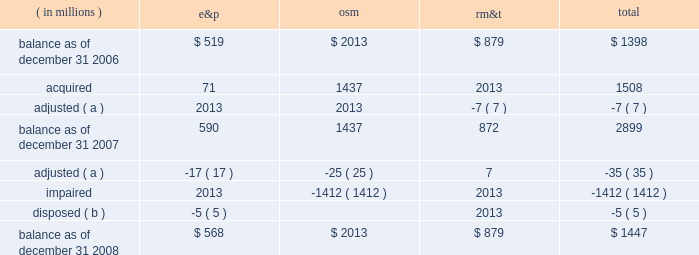Marathon oil corporation notes to consolidated financial statements the changes in the carrying amount of goodwill for the years ended december 31 , 2007 , and 2008 , were as follows : ( in millions ) e&p osm rm&t total .
( a ) adjustments related to prior period income tax and royalty adjustments .
( b ) goodwill was allocated to the norwegian outside-operated properties sold in 2008 .
17 .
Fair value measurements as defined in sfas no .
157 , fair value is the price that would be received to sell an asset or paid to transfer a liability in an orderly transaction between market participants at the measurement date .
Sfas no .
157 describes three approaches to measuring the fair value of assets and liabilities : the market approach , the income approach and the cost approach , each of which includes multiple valuation techniques .
The market approach uses prices and other relevant information generated by market transactions involving identical or comparable assets or liabilities .
The income approach uses valuation techniques to measure fair value by converting future amounts , such as cash flows or earnings , into a single present value amount using current market expectations about those future amounts .
The cost approach is based on the amount that would currently be required to replace the service capacity of an asset .
This is often referred to as current replacement cost .
The cost approach assumes that the fair value would not exceed what it would cost a market participant to acquire or construct a substitute asset of comparable utility , adjusted for obsolescence .
Sfas no .
157 does not prescribe which valuation technique should be used when measuring fair value and does not prioritize among the techniques .
Sfas no .
157 establishes a fair value hierarchy that prioritizes the inputs used in applying the various valuation techniques .
Inputs broadly refer to the assumptions that market participants use to make pricing decisions , including assumptions about risk .
Level 1 inputs are given the highest priority in the fair value hierarchy while level 3 inputs are given the lowest priority .
The three levels of the fair value hierarchy are as follows .
2022 level 1 2013 observable inputs that reflect unadjusted quoted prices for identical assets or liabilities in active markets as of the reporting date .
Active markets are those in which transactions for the asset or liability occur in sufficient frequency and volume to provide pricing information on an ongoing basis .
2022 level 2 2013 observable market-based inputs or unobservable inputs that are corroborated by market data .
These are inputs other than quoted prices in active markets included in level 1 , which are either directly or indirectly observable as of the reporting date .
2022 level 3 2013 unobservable inputs that are not corroborated by market data and may be used with internally developed methodologies that result in management 2019s best estimate of fair value .
We use a market or income approach for recurring fair value measurements and endeavor to use the best information available .
Accordingly , valuation techniques that maximize the use of observable inputs are favored .
Financial assets and liabilities are classified in their entirety based on the lowest priority level of input that is significant to the fair value measurement .
The assessment of the significance of a particular input to the fair value measurement requires judgment and may affect the placement of assets and liabilities within the levels of the fair value hierarchy. .
By what percentage did total goodwill decline from 2007 to 2008 year end? 
Computations: ((2899 - 1447) / 2899)
Answer: 0.50086. 